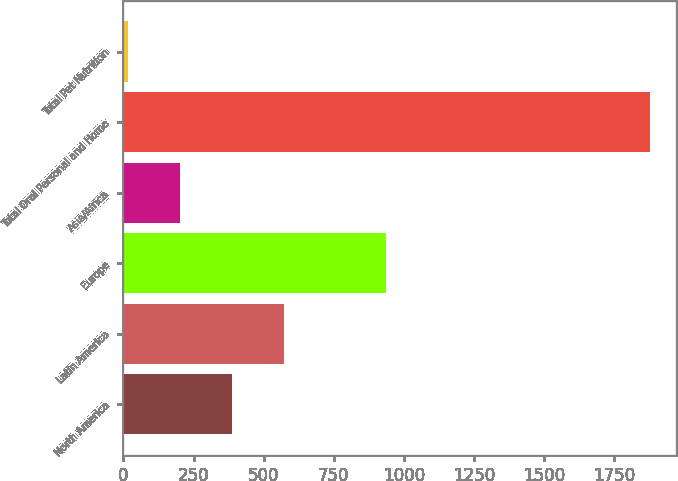<chart> <loc_0><loc_0><loc_500><loc_500><bar_chart><fcel>North America<fcel>Latin America<fcel>Europe<fcel>Asia/Africa<fcel>Total Oral Personal and Home<fcel>Total Pet Nutrition<nl><fcel>387.34<fcel>573.51<fcel>936.5<fcel>201.17<fcel>1876.7<fcel>15<nl></chart> 